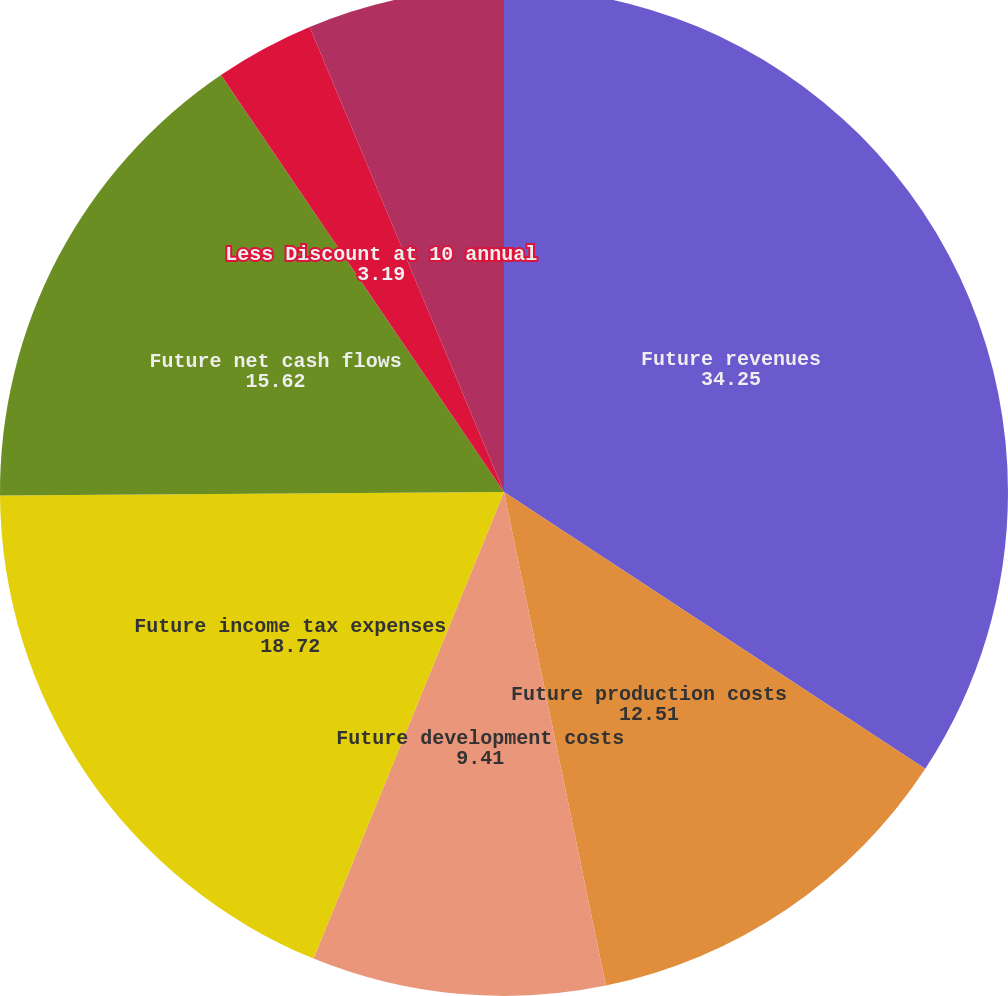Convert chart to OTSL. <chart><loc_0><loc_0><loc_500><loc_500><pie_chart><fcel>Future revenues<fcel>Future production costs<fcel>Future development costs<fcel>Future income tax expenses<fcel>Future net cash flows<fcel>Less Discount at 10 annual<fcel>Standardized measure of<nl><fcel>34.25%<fcel>12.51%<fcel>9.41%<fcel>18.72%<fcel>15.62%<fcel>3.19%<fcel>6.3%<nl></chart> 